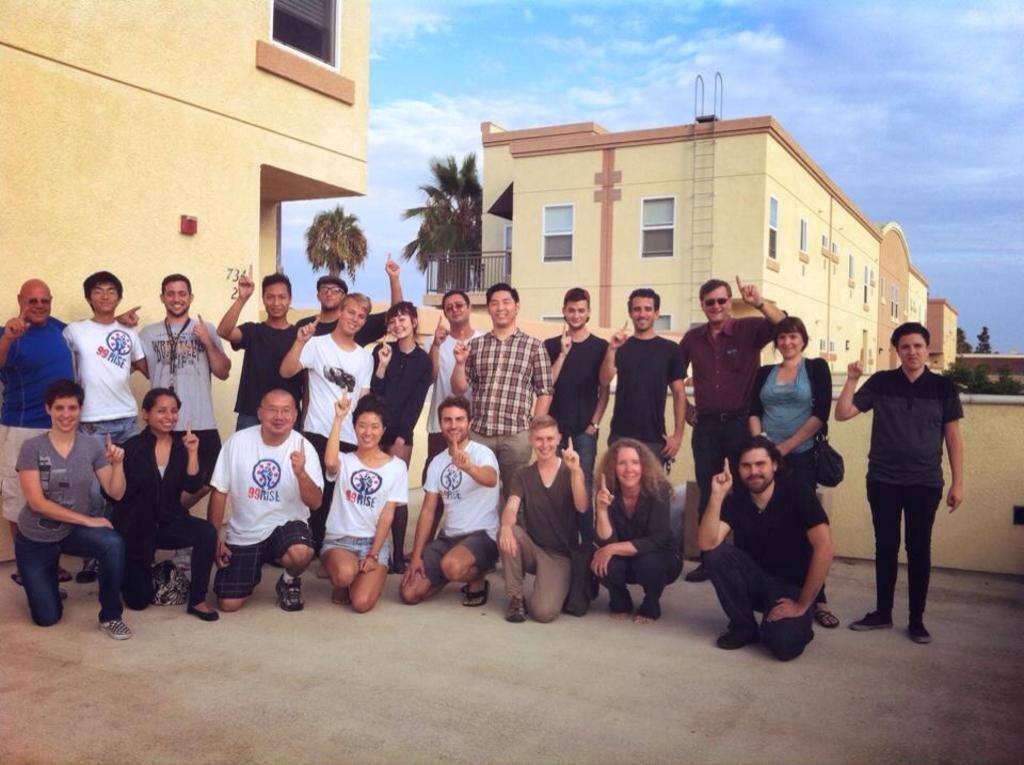Who are the people in the image? There is a man and a woman in the image. What are the man and the woman doing in the image? Both the man and the woman are standing and bending on their knees. What can be seen in the background of the image? There are buildings and trees in the background of the image. How would you describe the sky in the image? The sky is blue with some clouds. What type of bread is being used as a chair in the image? There is no bread or chair present in the image. Can you tell me how many calculators are visible in the image? There are no calculators visible in the image. 